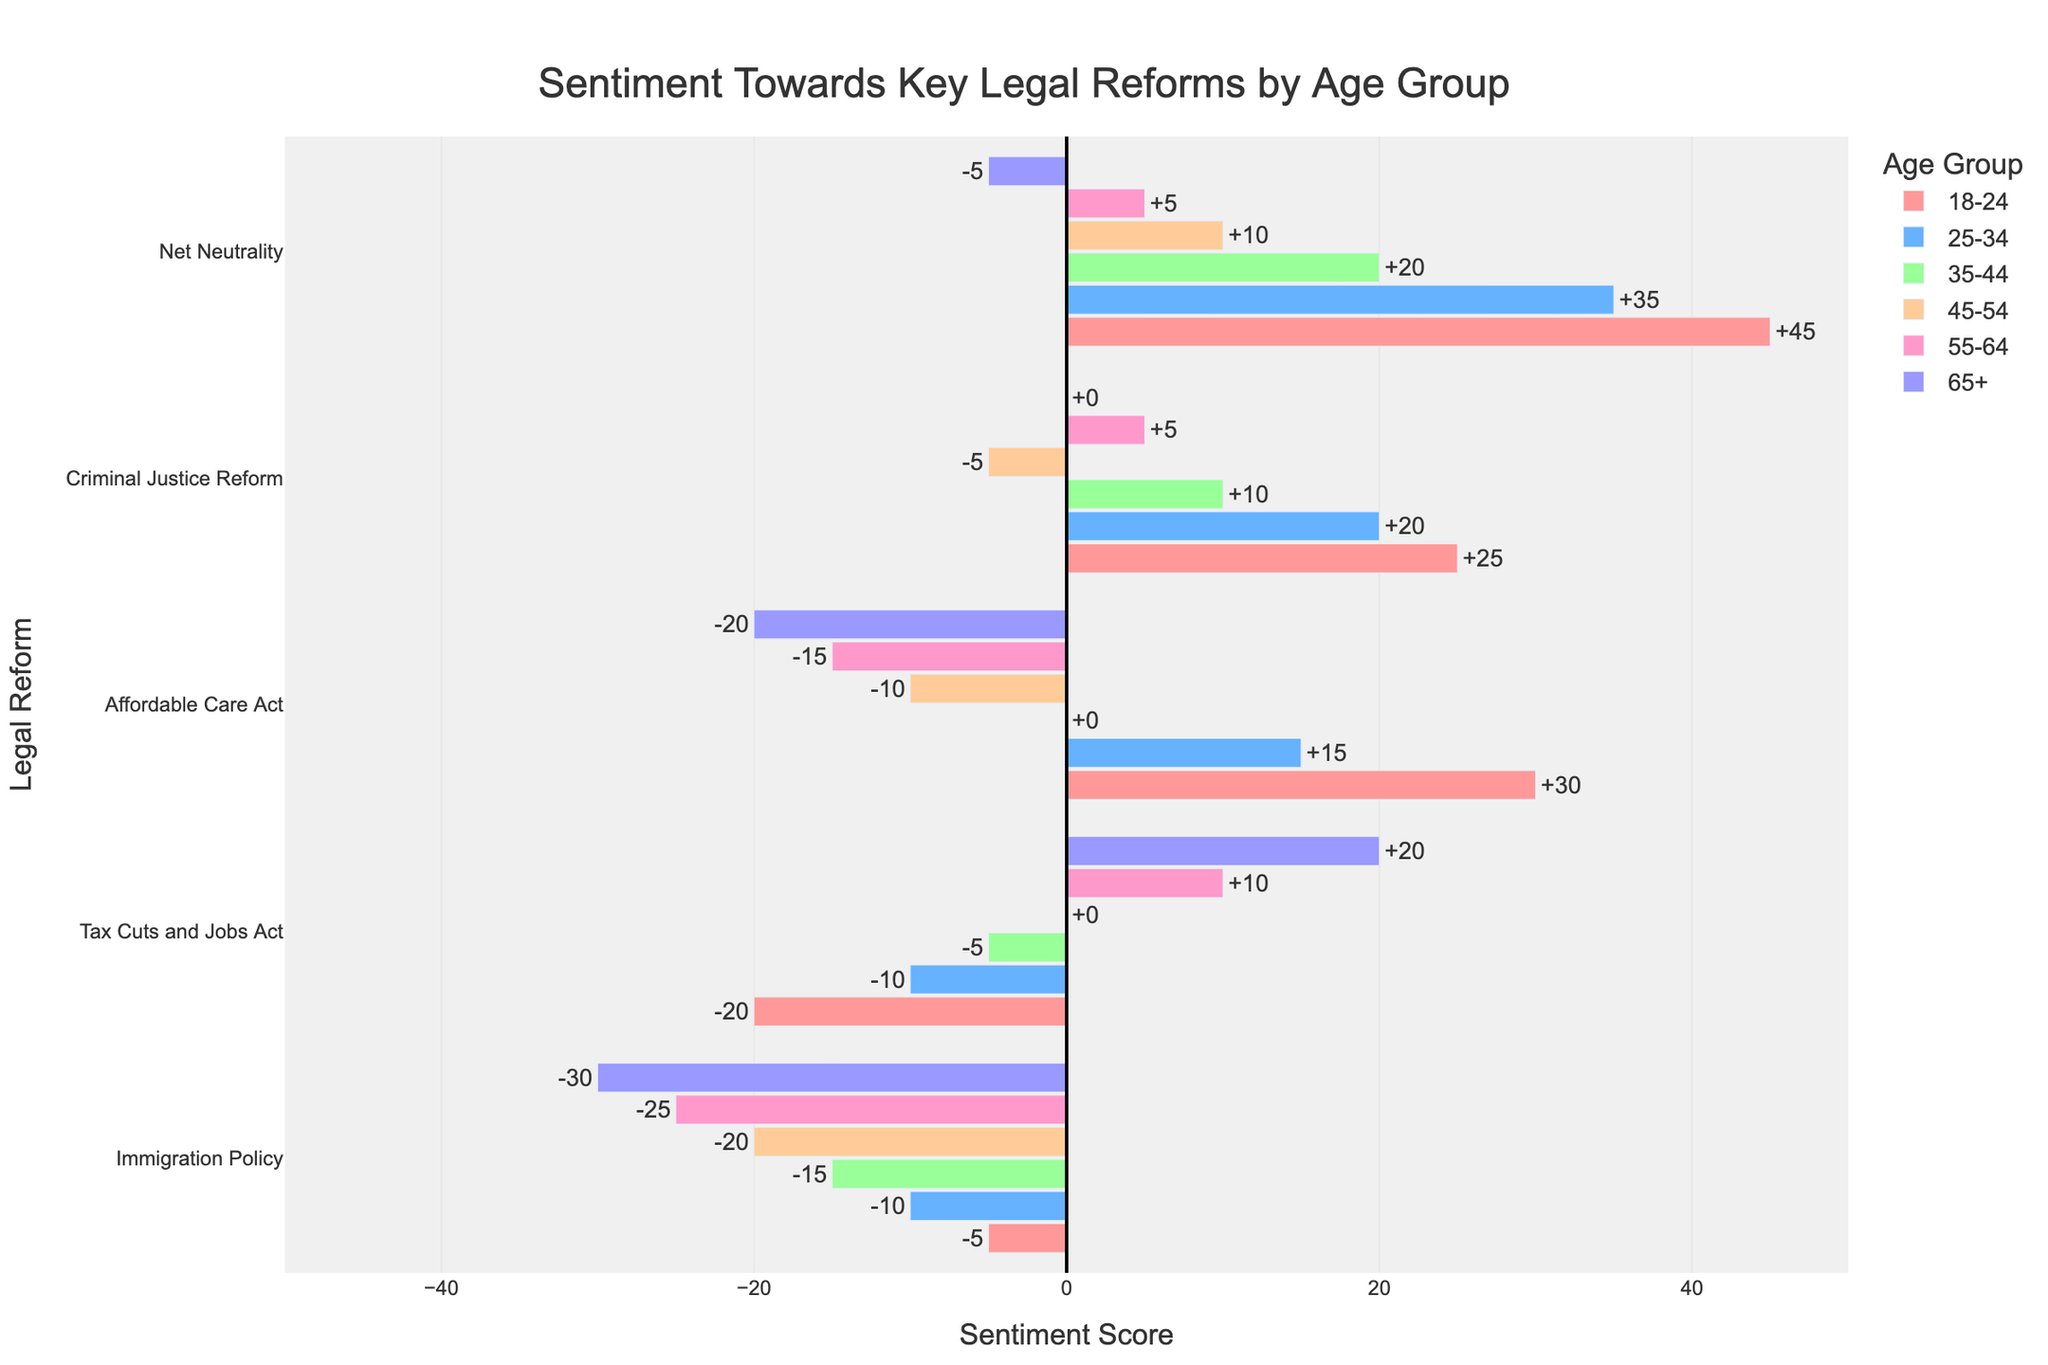What age group has the most positive sentiment towards Net Neutrality? Look at the bars for Net Neutrality. The 18-24 age group has the tallest bar extending to the right, indicating the highest positive sentiment.
Answer: 18-24 What is the difference in sentiment towards the Affordable Care Act between the 18-24 age group and the 65+ age group? The sentiment score for the 18-24 age group is +30, and for the 65+ age group, it is -20. The difference is 30 - (-20) = 50.
Answer: 50 Which age group has the most negative sentiment towards Immigration Policy? Observe the bars for Immigration Policy. The 65+ age group has the longest bar extending to the left, indicating the most negative sentiment.
Answer: 65+ What is the average sentiment score towards Criminal Justice Reform across all age groups? Sum up the sentiment scores for Criminal Justice Reform: 25 + 20 + 10 - 5 + 5 + 0 = 55. Divide by the number of age groups (6): 55 / 6 ≈ 9.17.
Answer: 9.17 How does the sentiment score for the Tax Cuts and Jobs Act in the 55-64 age group compare to the 18-24 age group? The sentiment score for the 55-64 age group is +10, while for the 18-24 age group, it is -20. The 55-64 age group has a more positive sentiment by 30 points.
Answer: 55-64 > 18-24 Which legal reform had a neutral sentiment (0 score) in the 35-44 age group? Find the bar for the 35-44 age group that is positioned exactly at the vertical axis (x=0). The Affordable Care Act has a sentiment score of 0.
Answer: Affordable Care Act What is the combined sentiment score for the Affordable Care Act and Net Neutrality in the 25-34 age group? The sentiment score for the Affordable Care Act is +15, and for Net Neutrality, it is +35. The combined score is 15 + 35 = 50.
Answer: 50 Compare the sentiment towards Criminal Justice Reform between the youngest and oldest age groups. The sentiment score for the 18-24 age group is +25, and for the 65+ age group, it is 0. The 18-24 age group is more positive by 25 points.
Answer: 18-24 > 65+ Which age group shows a negative sentiment for the most number of legal reforms? Count the number of bars extending to the left for each age group. The 65+ age group shows a negative sentiment for Affordable Care Act, Immigration Policy, and Net Neutrality, totaling 3 reforms.
Answer: 65+ What is the sentiment score for Immigration Policy in the 25-34 age group, and how does it compare to the 45-54 age group? The sentiment score for the 25-34 age group is -10, and for the 45-54 age group, it is -20. The 25-34 age group is more positive by 10 points.
Answer: 25-34 > 45-54 